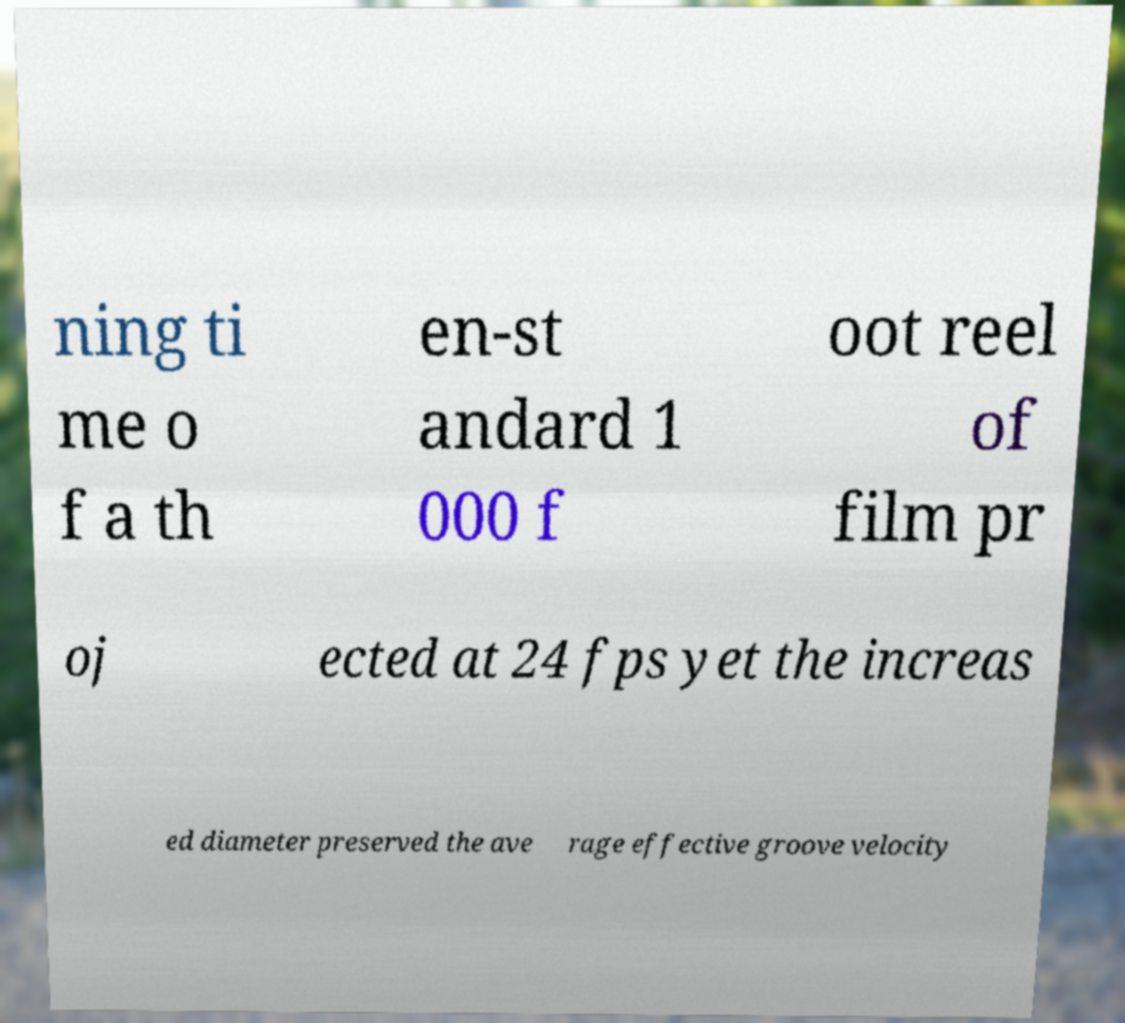Please read and relay the text visible in this image. What does it say? ning ti me o f a th en-st andard 1 000 f oot reel of film pr oj ected at 24 fps yet the increas ed diameter preserved the ave rage effective groove velocity 